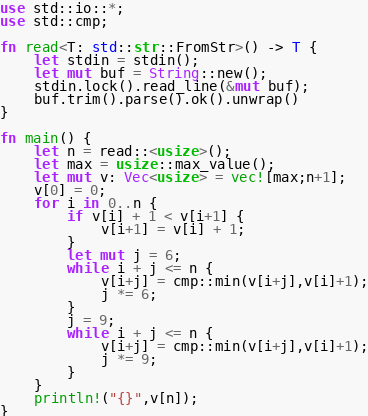<code> <loc_0><loc_0><loc_500><loc_500><_Rust_>use std::io::*;
use std::cmp;

fn read<T: std::str::FromStr>() -> T {
    let stdin = stdin();
    let mut buf = String::new();
	stdin.lock().read_line(&mut buf);
	buf.trim().parse().ok().unwrap()
}

fn main() {
    let n = read::<usize>();
    let max = usize::max_value();
    let mut v: Vec<usize> = vec![max;n+1];
    v[0] = 0;
    for i in 0..n {
        if v[i] + 1 < v[i+1] {
            v[i+1] = v[i] + 1;
        }
        let mut j = 6;
        while i + j <= n {
            v[i+j] = cmp::min(v[i+j],v[i]+1);
            j *= 6;
        }
        j = 9;
        while i + j <= n {
            v[i+j] = cmp::min(v[i+j],v[i]+1);
            j *= 9;
        }
    }
    println!("{}",v[n]);
}
</code> 